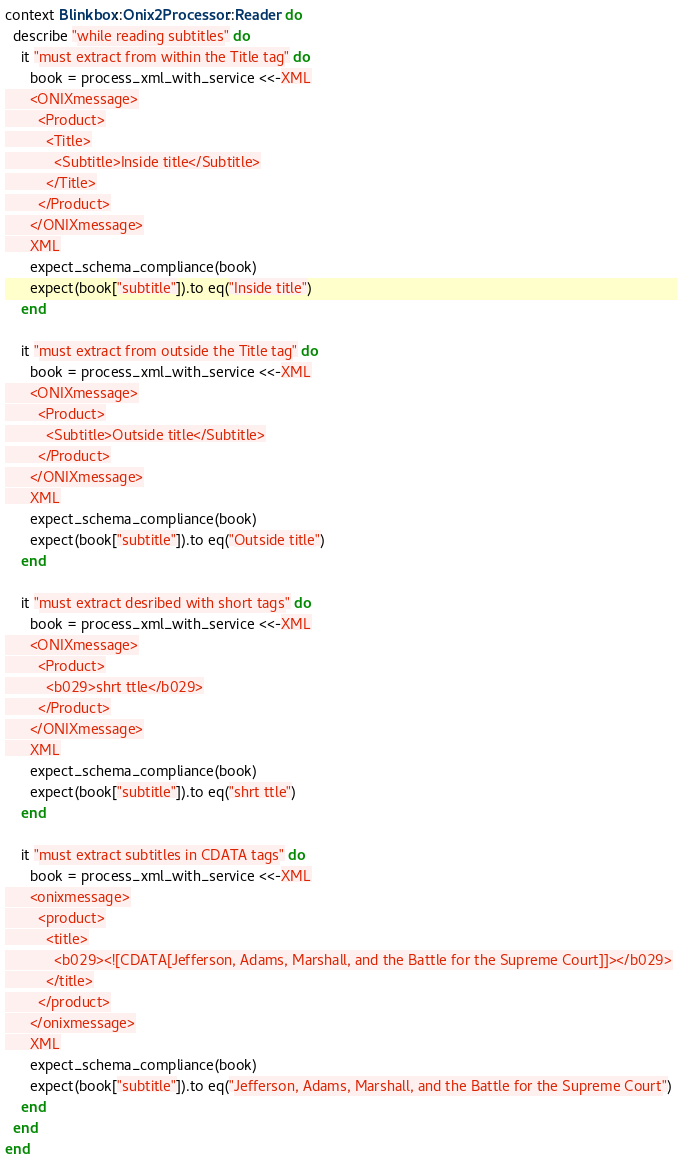<code> <loc_0><loc_0><loc_500><loc_500><_Ruby_>context Blinkbox::Onix2Processor::Reader do
  describe "while reading subtitles" do
    it "must extract from within the Title tag" do
      book = process_xml_with_service <<-XML
      <ONIXmessage>
        <Product>
          <Title>
            <Subtitle>Inside title</Subtitle>
          </Title>
        </Product>
      </ONIXmessage>
      XML
      expect_schema_compliance(book)
      expect(book["subtitle"]).to eq("Inside title")
    end

    it "must extract from outside the Title tag" do
      book = process_xml_with_service <<-XML
      <ONIXmessage>
        <Product>
          <Subtitle>Outside title</Subtitle>
        </Product>
      </ONIXmessage>
      XML
      expect_schema_compliance(book)
      expect(book["subtitle"]).to eq("Outside title")
    end

    it "must extract desribed with short tags" do
      book = process_xml_with_service <<-XML
      <ONIXmessage>
        <Product>
          <b029>shrt ttle</b029>
        </Product>
      </ONIXmessage>
      XML
      expect_schema_compliance(book)
      expect(book["subtitle"]).to eq("shrt ttle")
    end

    it "must extract subtitles in CDATA tags" do
      book = process_xml_with_service <<-XML
      <onixmessage>
        <product>
          <title>
            <b029><![CDATA[Jefferson, Adams, Marshall, and the Battle for the Supreme Court]]></b029>
          </title>
        </product>
      </onixmessage>
      XML
      expect_schema_compliance(book)
      expect(book["subtitle"]).to eq("Jefferson, Adams, Marshall, and the Battle for the Supreme Court")
    end
  end
end</code> 